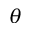Convert formula to latex. <formula><loc_0><loc_0><loc_500><loc_500>\theta</formula> 